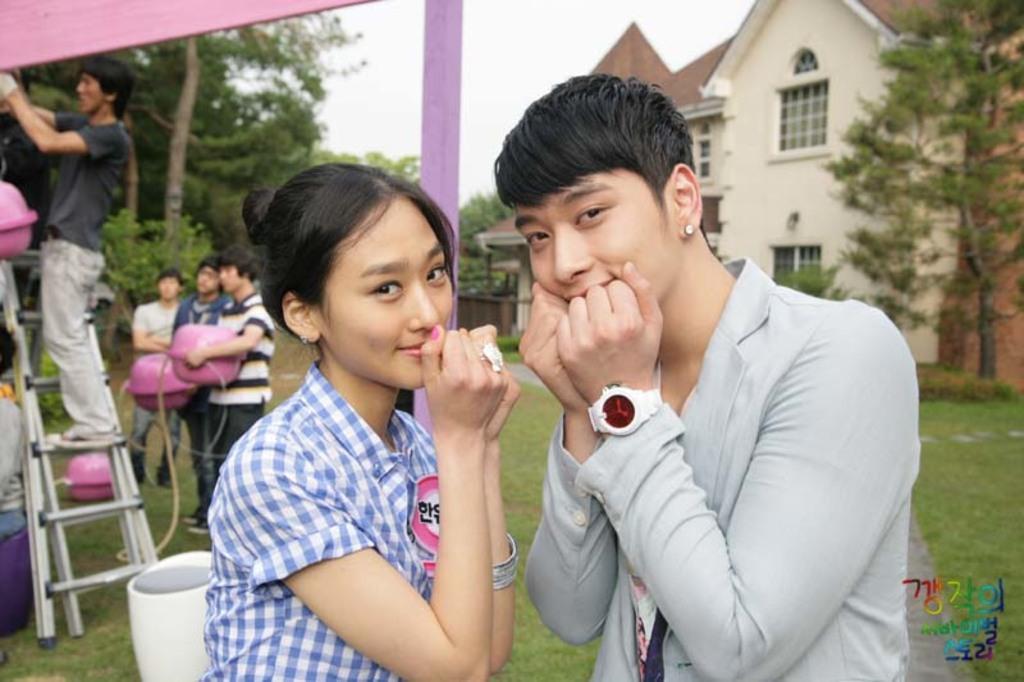Can you describe this image briefly? In this image I can see a woman wearing blue and white colored dress and a man wearing blue colored dress. I can see a pink colored pole, a ladder and a person on the ladder, few persons standing and holding pink colored objects. In the background I can see few trees, a house and the sky. 